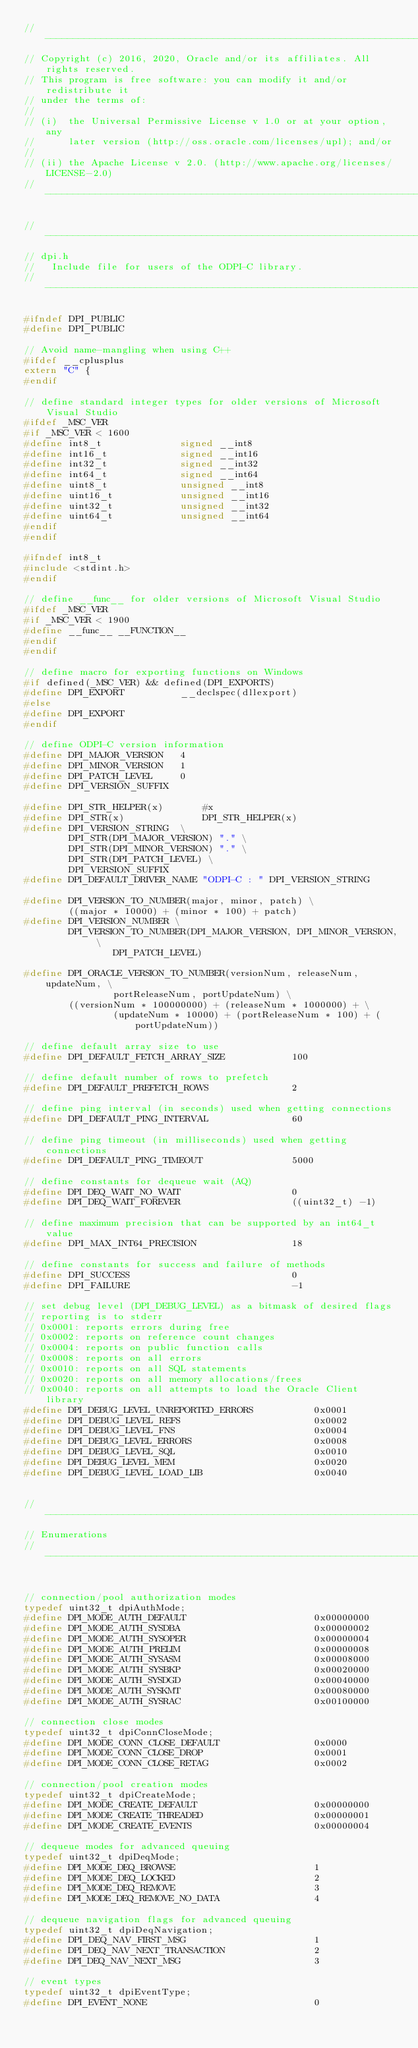Convert code to text. <code><loc_0><loc_0><loc_500><loc_500><_C_>//-----------------------------------------------------------------------------
// Copyright (c) 2016, 2020, Oracle and/or its affiliates. All rights reserved.
// This program is free software: you can modify it and/or redistribute it
// under the terms of:
//
// (i)  the Universal Permissive License v 1.0 or at your option, any
//      later version (http://oss.oracle.com/licenses/upl); and/or
//
// (ii) the Apache License v 2.0. (http://www.apache.org/licenses/LICENSE-2.0)
//-----------------------------------------------------------------------------

//-----------------------------------------------------------------------------
// dpi.h
//   Include file for users of the ODPI-C library.
//-----------------------------------------------------------------------------

#ifndef DPI_PUBLIC
#define DPI_PUBLIC

// Avoid name-mangling when using C++
#ifdef __cplusplus
extern "C" {
#endif

// define standard integer types for older versions of Microsoft Visual Studio
#ifdef _MSC_VER
#if _MSC_VER < 1600
#define int8_t              signed __int8
#define int16_t             signed __int16
#define int32_t             signed __int32
#define int64_t             signed __int64
#define uint8_t             unsigned __int8
#define uint16_t            unsigned __int16
#define uint32_t            unsigned __int32
#define uint64_t            unsigned __int64
#endif
#endif

#ifndef int8_t
#include <stdint.h>
#endif

// define __func__ for older versions of Microsoft Visual Studio
#ifdef _MSC_VER
#if _MSC_VER < 1900
#define __func__ __FUNCTION__
#endif
#endif

// define macro for exporting functions on Windows
#if defined(_MSC_VER) && defined(DPI_EXPORTS)
#define DPI_EXPORT          __declspec(dllexport)
#else
#define DPI_EXPORT
#endif

// define ODPI-C version information
#define DPI_MAJOR_VERSION   4
#define DPI_MINOR_VERSION   1
#define DPI_PATCH_LEVEL     0
#define DPI_VERSION_SUFFIX

#define DPI_STR_HELPER(x)       #x
#define DPI_STR(x)              DPI_STR_HELPER(x)
#define DPI_VERSION_STRING  \
        DPI_STR(DPI_MAJOR_VERSION) "." \
        DPI_STR(DPI_MINOR_VERSION) "." \
        DPI_STR(DPI_PATCH_LEVEL) \
        DPI_VERSION_SUFFIX
#define DPI_DEFAULT_DRIVER_NAME "ODPI-C : " DPI_VERSION_STRING

#define DPI_VERSION_TO_NUMBER(major, minor, patch) \
        ((major * 10000) + (minor * 100) + patch)
#define DPI_VERSION_NUMBER \
        DPI_VERSION_TO_NUMBER(DPI_MAJOR_VERSION, DPI_MINOR_VERSION, \
                DPI_PATCH_LEVEL)

#define DPI_ORACLE_VERSION_TO_NUMBER(versionNum, releaseNum, updateNum, \
                portReleaseNum, portUpdateNum) \
        ((versionNum * 100000000) + (releaseNum * 1000000) + \
                (updateNum * 10000) + (portReleaseNum * 100) + (portUpdateNum))

// define default array size to use
#define DPI_DEFAULT_FETCH_ARRAY_SIZE            100

// define default number of rows to prefetch
#define DPI_DEFAULT_PREFETCH_ROWS               2

// define ping interval (in seconds) used when getting connections
#define DPI_DEFAULT_PING_INTERVAL               60

// define ping timeout (in milliseconds) used when getting connections
#define DPI_DEFAULT_PING_TIMEOUT                5000

// define constants for dequeue wait (AQ)
#define DPI_DEQ_WAIT_NO_WAIT                    0
#define DPI_DEQ_WAIT_FOREVER                    ((uint32_t) -1)

// define maximum precision that can be supported by an int64_t value
#define DPI_MAX_INT64_PRECISION                 18

// define constants for success and failure of methods
#define DPI_SUCCESS                             0
#define DPI_FAILURE                             -1

// set debug level (DPI_DEBUG_LEVEL) as a bitmask of desired flags
// reporting is to stderr
// 0x0001: reports errors during free
// 0x0002: reports on reference count changes
// 0x0004: reports on public function calls
// 0x0008: reports on all errors
// 0x0010: reports on all SQL statements
// 0x0020: reports on all memory allocations/frees
// 0x0040: reports on all attempts to load the Oracle Client library
#define DPI_DEBUG_LEVEL_UNREPORTED_ERRORS           0x0001
#define DPI_DEBUG_LEVEL_REFS                        0x0002
#define DPI_DEBUG_LEVEL_FNS                         0x0004
#define DPI_DEBUG_LEVEL_ERRORS                      0x0008
#define DPI_DEBUG_LEVEL_SQL                         0x0010
#define DPI_DEBUG_LEVEL_MEM                         0x0020
#define DPI_DEBUG_LEVEL_LOAD_LIB                    0x0040


//-----------------------------------------------------------------------------
// Enumerations
//-----------------------------------------------------------------------------


// connection/pool authorization modes
typedef uint32_t dpiAuthMode;
#define DPI_MODE_AUTH_DEFAULT                       0x00000000
#define DPI_MODE_AUTH_SYSDBA                        0x00000002
#define DPI_MODE_AUTH_SYSOPER                       0x00000004
#define DPI_MODE_AUTH_PRELIM                        0x00000008
#define DPI_MODE_AUTH_SYSASM                        0x00008000
#define DPI_MODE_AUTH_SYSBKP                        0x00020000
#define DPI_MODE_AUTH_SYSDGD                        0x00040000
#define DPI_MODE_AUTH_SYSKMT                        0x00080000
#define DPI_MODE_AUTH_SYSRAC                        0x00100000

// connection close modes
typedef uint32_t dpiConnCloseMode;
#define DPI_MODE_CONN_CLOSE_DEFAULT                 0x0000
#define DPI_MODE_CONN_CLOSE_DROP                    0x0001
#define DPI_MODE_CONN_CLOSE_RETAG                   0x0002

// connection/pool creation modes
typedef uint32_t dpiCreateMode;
#define DPI_MODE_CREATE_DEFAULT                     0x00000000
#define DPI_MODE_CREATE_THREADED                    0x00000001
#define DPI_MODE_CREATE_EVENTS                      0x00000004

// dequeue modes for advanced queuing
typedef uint32_t dpiDeqMode;
#define DPI_MODE_DEQ_BROWSE                         1
#define DPI_MODE_DEQ_LOCKED                         2
#define DPI_MODE_DEQ_REMOVE                         3
#define DPI_MODE_DEQ_REMOVE_NO_DATA                 4

// dequeue navigation flags for advanced queuing
typedef uint32_t dpiDeqNavigation;
#define DPI_DEQ_NAV_FIRST_MSG                       1
#define DPI_DEQ_NAV_NEXT_TRANSACTION                2
#define DPI_DEQ_NAV_NEXT_MSG                        3

// event types
typedef uint32_t dpiEventType;
#define DPI_EVENT_NONE                              0</code> 